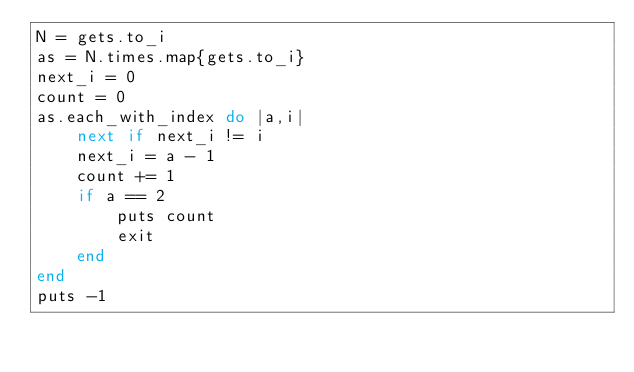<code> <loc_0><loc_0><loc_500><loc_500><_Ruby_>N = gets.to_i
as = N.times.map{gets.to_i}
next_i = 0
count = 0
as.each_with_index do |a,i|
    next if next_i != i
    next_i = a - 1
    count += 1
    if a == 2
        puts count
        exit
    end
end
puts -1
</code> 